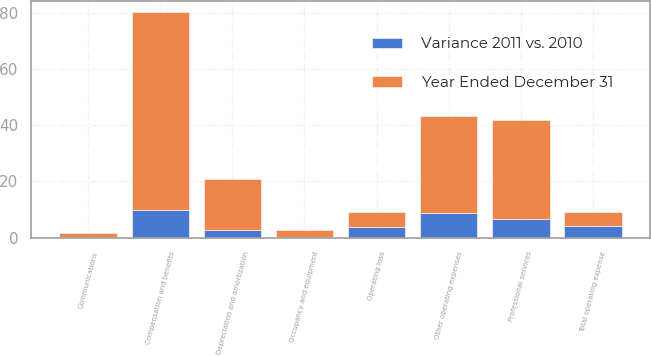Convert chart. <chart><loc_0><loc_0><loc_500><loc_500><stacked_bar_chart><ecel><fcel>Compensation and benefits<fcel>Professional services<fcel>Occupancy and equipment<fcel>Communications<fcel>Depreciation and amortization<fcel>Other operating expenses<fcel>Total operating expense<fcel>Operating loss<nl><fcel>Year Ended December 31<fcel>70.3<fcel>35.4<fcel>2.7<fcel>1.5<fcel>18.4<fcel>34.5<fcel>5.25<fcel>5.25<nl><fcel>Variance 2011 vs. 2010<fcel>9.9<fcel>6.5<fcel>0.1<fcel>0.2<fcel>2.6<fcel>8.7<fcel>4<fcel>3.9<nl></chart> 